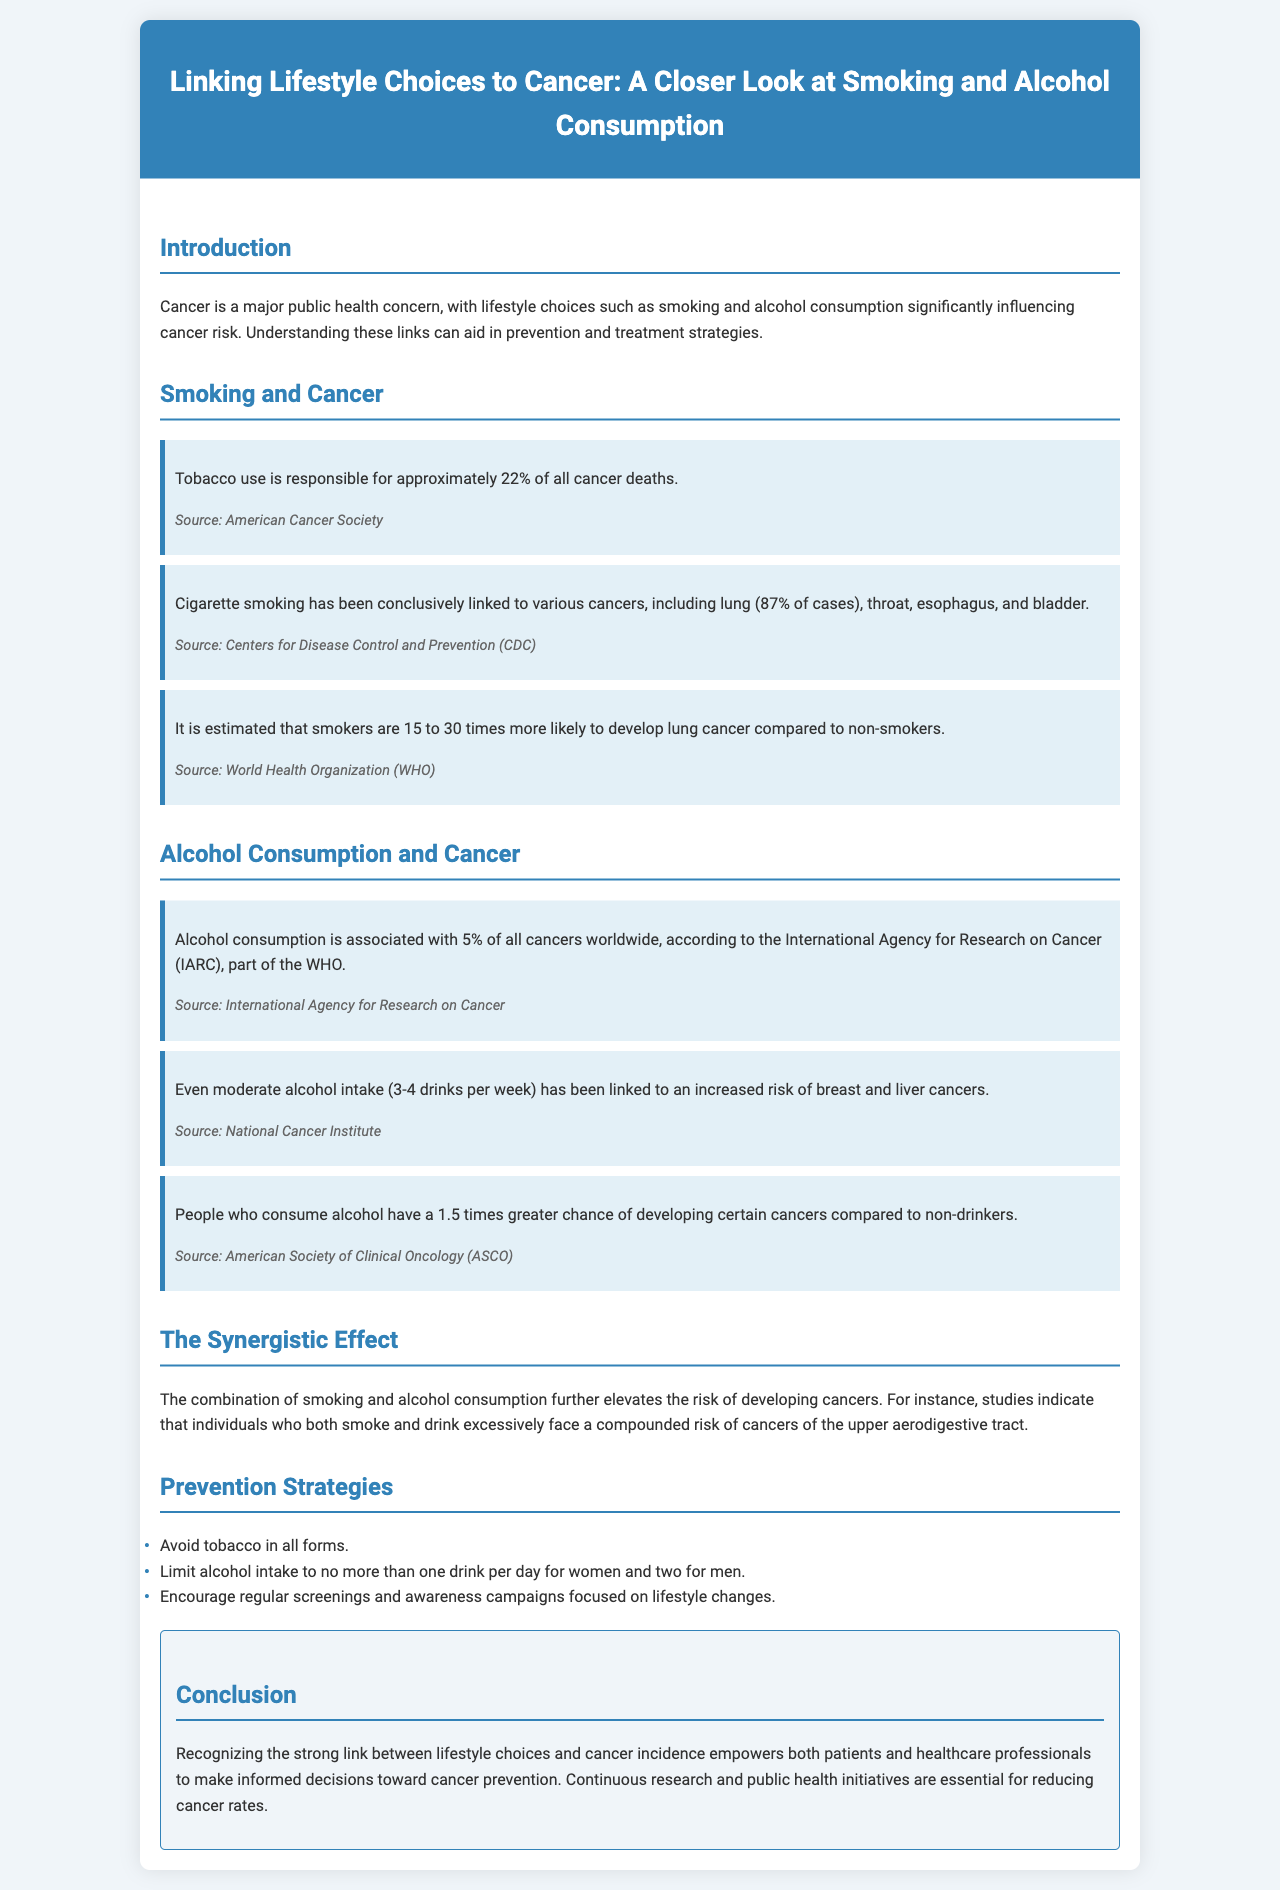What percentage of cancer deaths is attributable to tobacco use? The document states that tobacco use is responsible for approximately 22% of all cancer deaths.
Answer: 22% Which cancers have a definitive link to cigarette smoking? The document specifies that cigarette smoking has been conclusively linked to various cancers, including lung, throat, esophagus, and bladder.
Answer: Lung, throat, esophagus, bladder What is the estimated increased risk of lung cancer for smokers compared to non-smokers? According to the document, it is estimated that smokers are 15 to 30 times more likely to develop lung cancer compared to non-smokers.
Answer: 15 to 30 times What percentage of all cancers is associated with alcohol consumption? The document indicates that alcohol consumption is associated with 5% of all cancers worldwide.
Answer: 5% What is the added risk factor for people who consume alcohol in developing certain cancers compared to non-drinkers? The document mentions that people who consume alcohol have a 1.5 times greater chance of developing certain cancers compared to non-drinkers.
Answer: 1.5 times What lifestyle modifications are suggested to reduce cancer risk related to smoking and alcohol? The document lists several prevention strategies, including avoiding tobacco and limiting alcohol intake.
Answer: Avoid tobacco; limit alcohol intake Which cancers are mentioned in connection with moderate alcohol intake? The document states that moderate alcohol intake has been linked to an increased risk of breast and liver cancers.
Answer: Breast and liver What is the combined risk faced by individuals who both smoke and drink excessively? The document states that the combination of smoking and alcohol consumption further elevates the risk of developing cancers of the upper aerodigestive tract.
Answer: Compounded risk of cancers of the upper aerodigestive tract What organization is mentioned as the source for the 5% cancer association with alcohol? The document cites the International Agency for Research on Cancer as the source of this statistic.
Answer: International Agency for Research on Cancer 